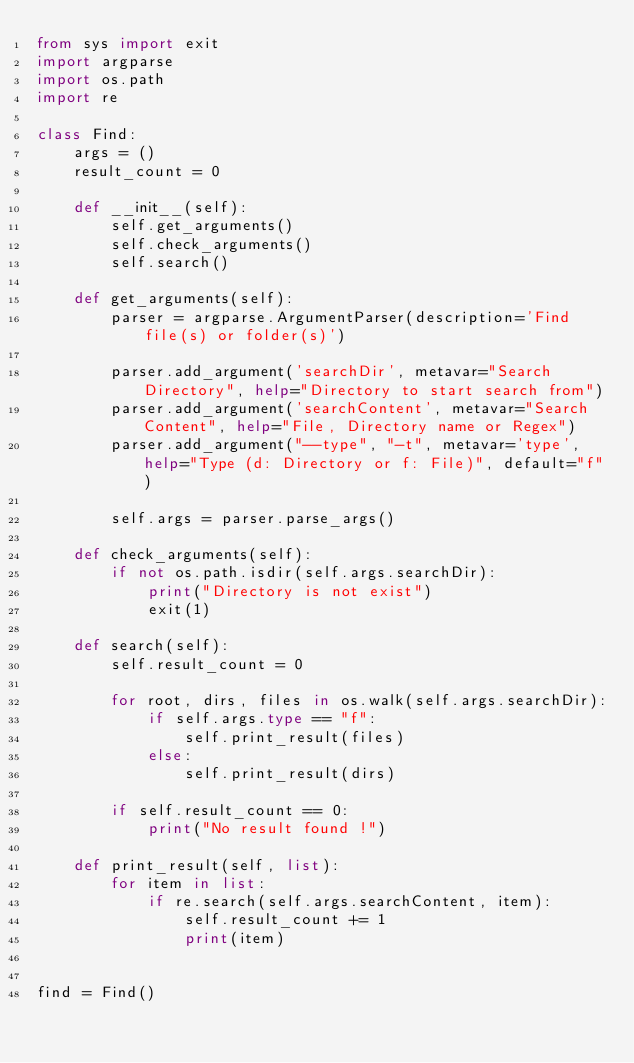Convert code to text. <code><loc_0><loc_0><loc_500><loc_500><_Python_>from sys import exit
import argparse
import os.path
import re

class Find:
    args = ()
    result_count = 0

    def __init__(self):
        self.get_arguments()
        self.check_arguments()
        self.search()

    def get_arguments(self):
        parser = argparse.ArgumentParser(description='Find file(s) or folder(s)')

        parser.add_argument('searchDir', metavar="Search Directory", help="Directory to start search from")
        parser.add_argument('searchContent', metavar="Search Content", help="File, Directory name or Regex")
        parser.add_argument("--type", "-t", metavar='type', help="Type (d: Directory or f: File)", default="f")

        self.args = parser.parse_args()

    def check_arguments(self):
        if not os.path.isdir(self.args.searchDir):
            print("Directory is not exist")
            exit(1)

    def search(self):
        self.result_count = 0

        for root, dirs, files in os.walk(self.args.searchDir):
            if self.args.type == "f":
                self.print_result(files)
            else:
                self.print_result(dirs)

        if self.result_count == 0:
            print("No result found !")

    def print_result(self, list):
        for item in list:
            if re.search(self.args.searchContent, item):
                self.result_count += 1
                print(item)


find = Find()
</code> 